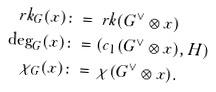Convert formula to latex. <formula><loc_0><loc_0><loc_500><loc_500>\ r k _ { G } ( x ) & \colon = \ r k ( G ^ { \vee } \otimes x ) \\ \deg _ { G } ( x ) & \colon = ( c _ { 1 } ( G ^ { \vee } \otimes x ) , H ) \\ \chi _ { G } ( x ) & \colon = \chi ( G ^ { \vee } \otimes x ) .</formula> 